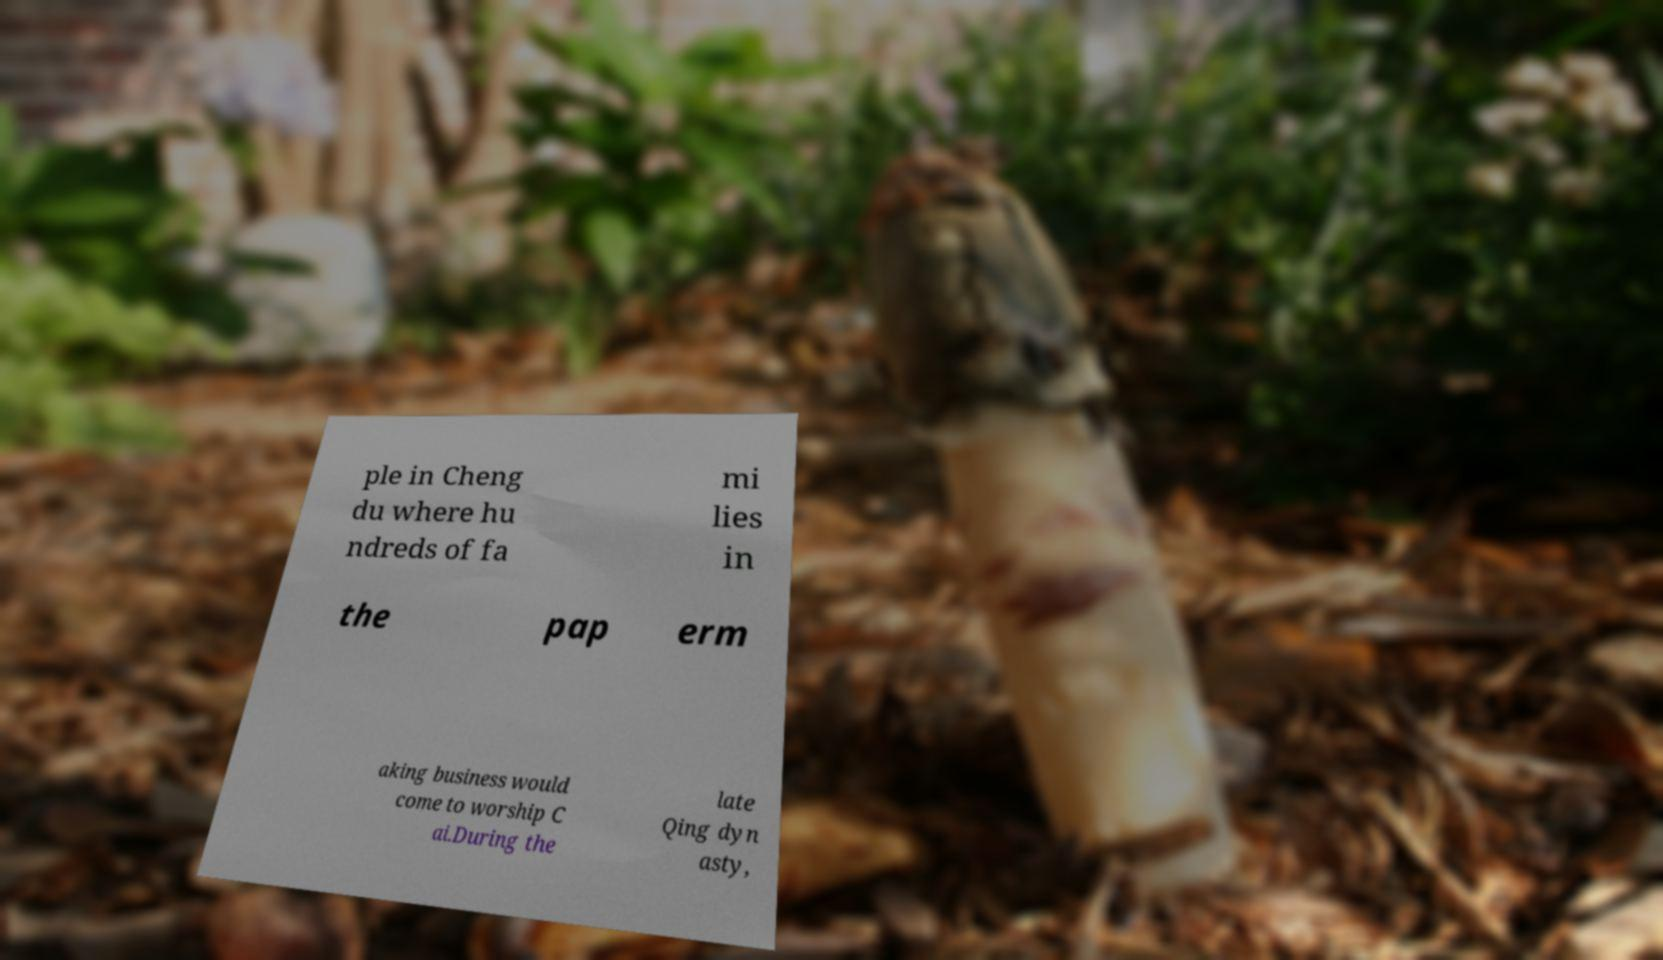Can you read and provide the text displayed in the image?This photo seems to have some interesting text. Can you extract and type it out for me? ple in Cheng du where hu ndreds of fa mi lies in the pap erm aking business would come to worship C ai.During the late Qing dyn asty, 